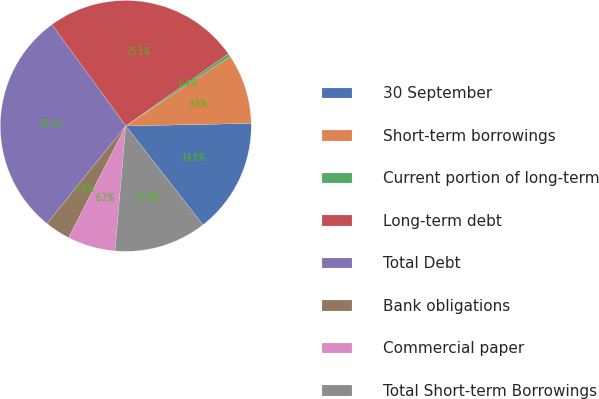<chart> <loc_0><loc_0><loc_500><loc_500><pie_chart><fcel>30 September<fcel>Short-term borrowings<fcel>Current portion of long-term<fcel>Long-term debt<fcel>Total Debt<fcel>Bank obligations<fcel>Commercial paper<fcel>Total Short-term Borrowings<nl><fcel>14.78%<fcel>9.03%<fcel>0.41%<fcel>25.26%<fcel>29.16%<fcel>3.28%<fcel>6.16%<fcel>11.91%<nl></chart> 